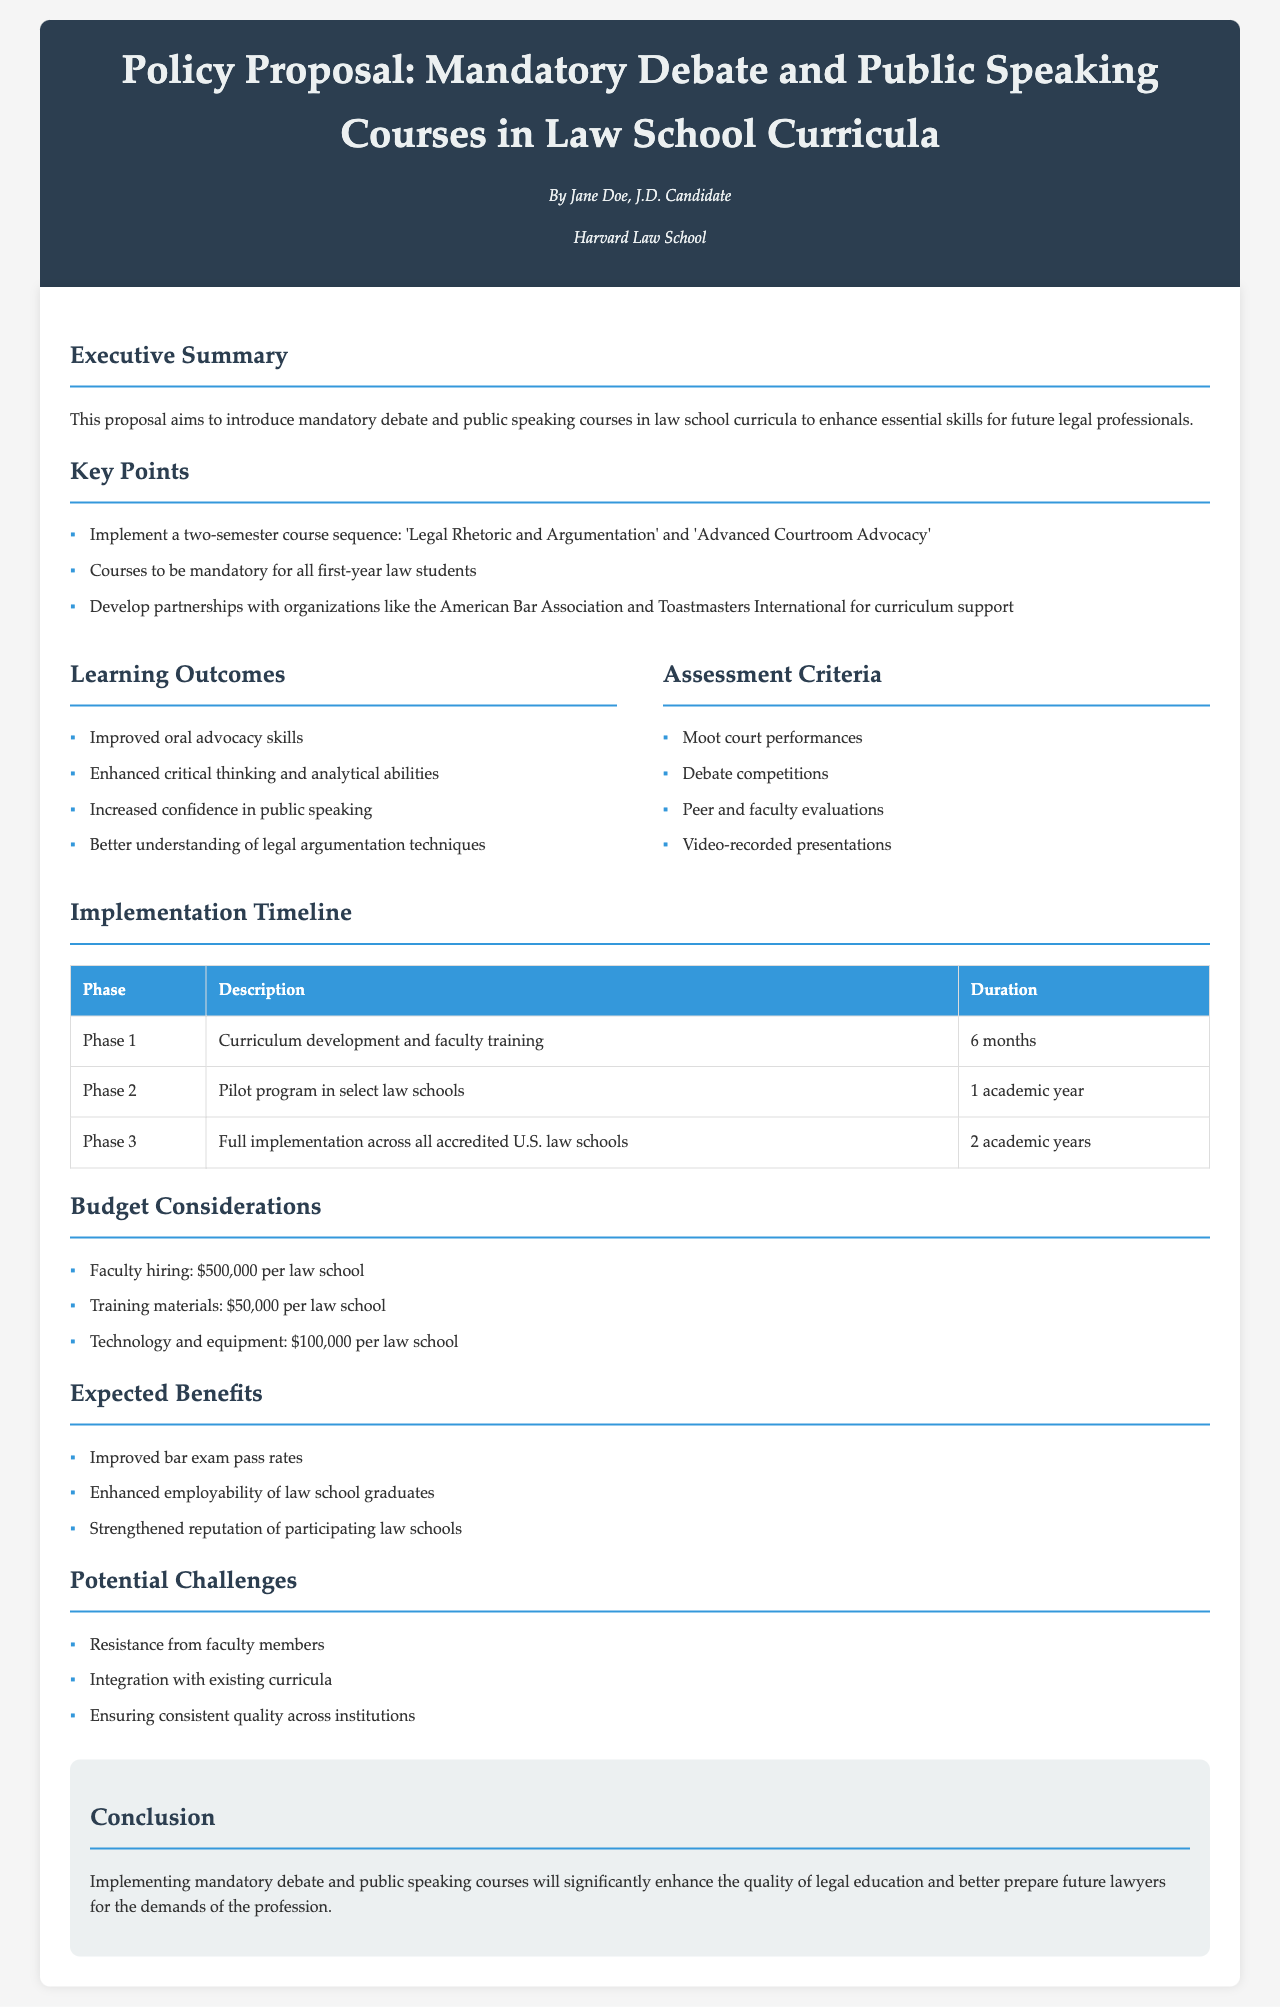What are the course titles? The titles of the courses are listed under Key Points, which states that the two-semester course sequence consists of 'Legal Rhetoric and Argumentation' and 'Advanced Courtroom Advocacy'.
Answer: Legal Rhetoric and Argumentation, Advanced Courtroom Advocacy Who is the author of the proposal? The author's information is found in the header section, indicating the author is Jane Doe, a J.D. Candidate from Harvard Law School.
Answer: Jane Doe What is the duration of Phase 1? The duration of Phase 1 is detailed in the Implementation Timeline table, indicating that it lasts for 6 months.
Answer: 6 months Which organization is mentioned for curriculum support? The proposal mentions developing partnerships with organizations in Key Points, specifying the American Bar Association for assistance.
Answer: American Bar Association What is one of the expected benefits? The expected benefits are listed in the document, one of which is improved bar exam pass rates.
Answer: Improved bar exam pass rates What assessment criteria involves recorded performances? The assessment criteria include video-recorded presentations, which are specified under the Assessment Criteria section.
Answer: Video-recorded presentations What phase involves pilot programs? The Implementation Timeline states that Phase 2 is dedicated to the pilot program in select law schools.
Answer: Phase 2 How much is allocated for faculty hiring per law school? The budget considerations specify that faculty hiring costs $500,000 per law school.
Answer: $500,000 